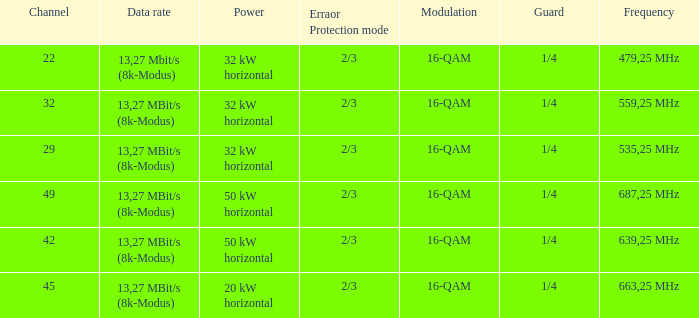On channel 32, when the power is 32 kW horizontal, what is the frequency? 559,25 MHz. 